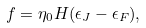Convert formula to latex. <formula><loc_0><loc_0><loc_500><loc_500>f = \eta _ { 0 } H ( \epsilon _ { J } - \epsilon _ { F } ) ,</formula> 